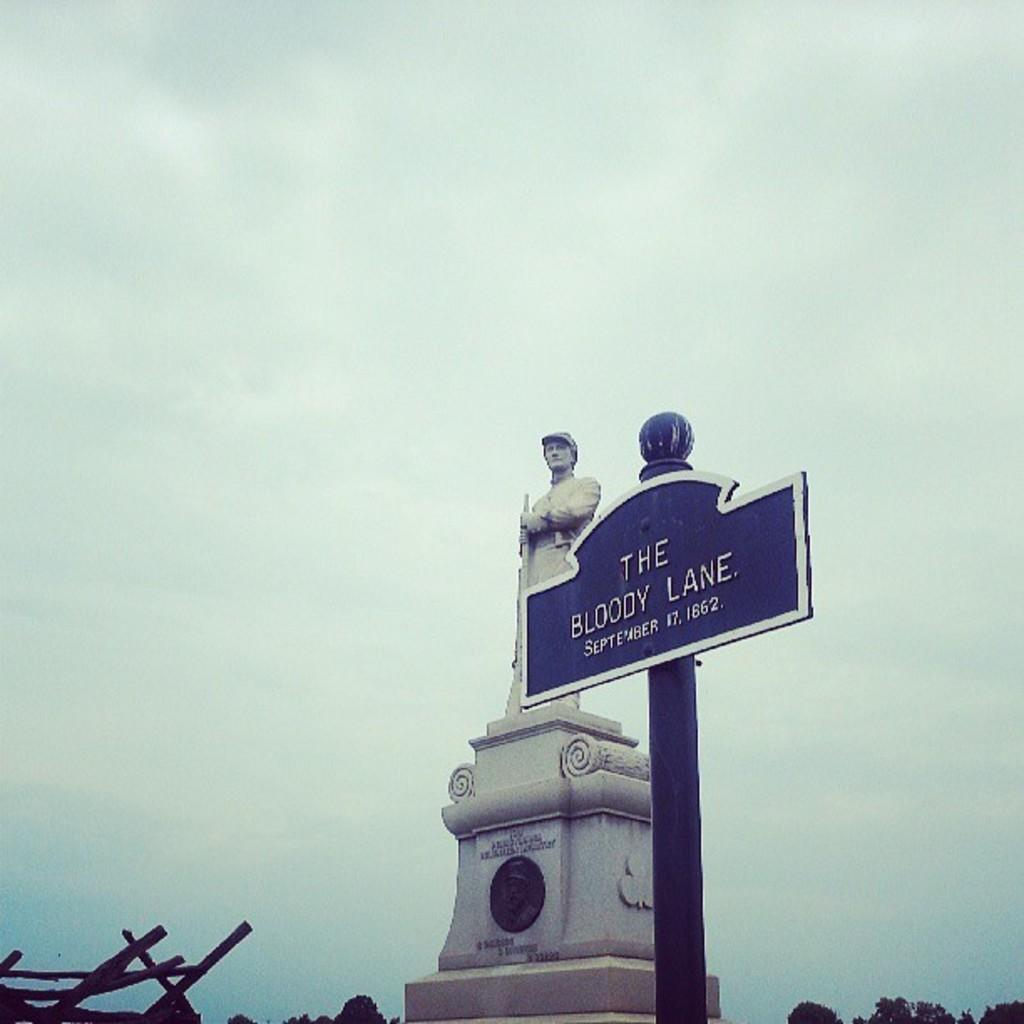What is the main object with a pole in the image? There is a name board with a pole in the image. What other object can be seen in the image? There is a statue in the image. What type of vegetation is present at the bottom of the image? There are sticks visible at the bottom of the image}. What type of natural scenery is visible in the image? There are trees in the image. What is visible in the background of the image? The sky is visible in the background of the image. What type of harmony is being played by the group in the image? There is no group or harmony present in the image; it features a name board, a statue, sticks, trees, and the sky. What type of collar is visible on the statue in the image? There is no collar visible on the statue in the image. 